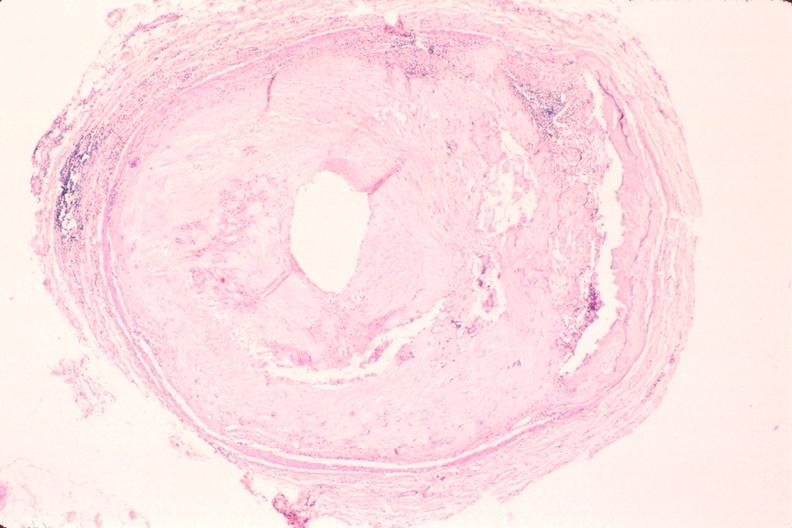what does this image show?
Answer the question using a single word or phrase. Atherosclerosis 